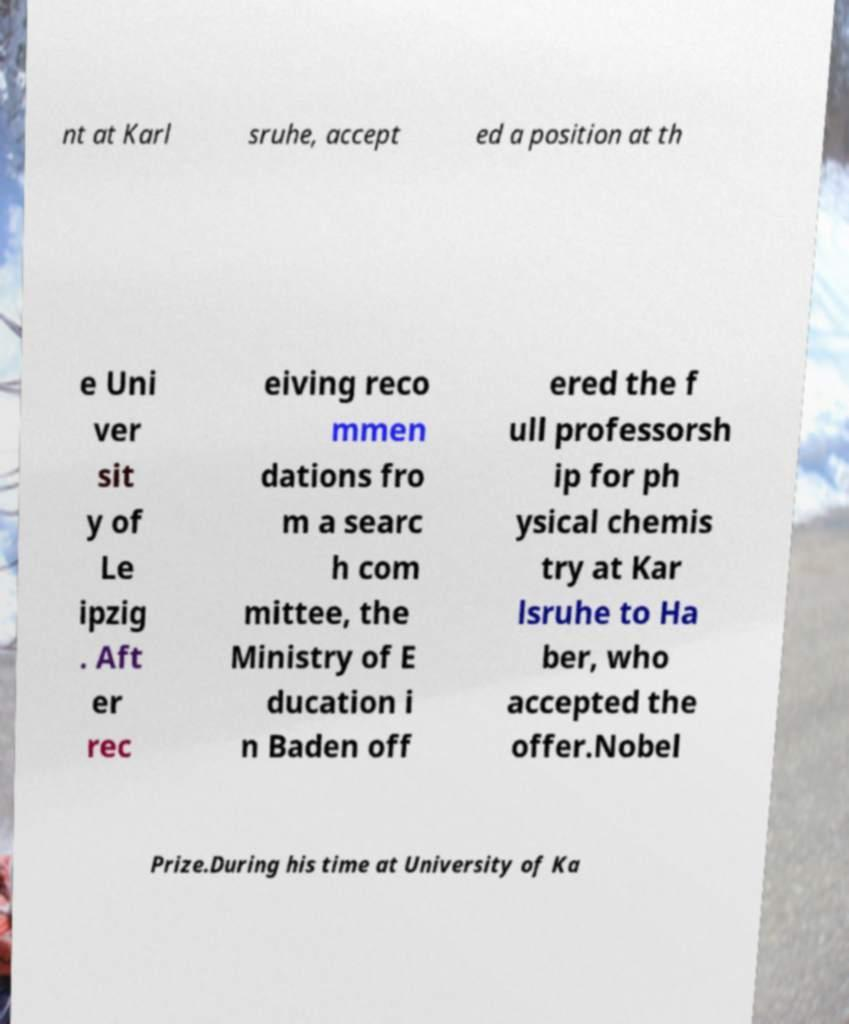I need the written content from this picture converted into text. Can you do that? nt at Karl sruhe, accept ed a position at th e Uni ver sit y of Le ipzig . Aft er rec eiving reco mmen dations fro m a searc h com mittee, the Ministry of E ducation i n Baden off ered the f ull professorsh ip for ph ysical chemis try at Kar lsruhe to Ha ber, who accepted the offer.Nobel Prize.During his time at University of Ka 